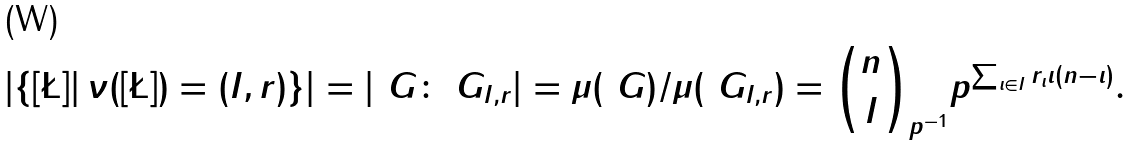<formula> <loc_0><loc_0><loc_500><loc_500>\left | \left \{ [ \L ] | \, \nu ( [ \L ] ) = ( I , r ) \right \} \right | = | \ G \colon \ G _ { I , r } | = \mu ( \ G ) / \mu ( \ G _ { I , r } ) = \binom { n } { I } _ { p ^ { - 1 } } p ^ { \sum _ { \iota \in I } r _ { \iota } \iota ( n - \iota ) } .</formula> 